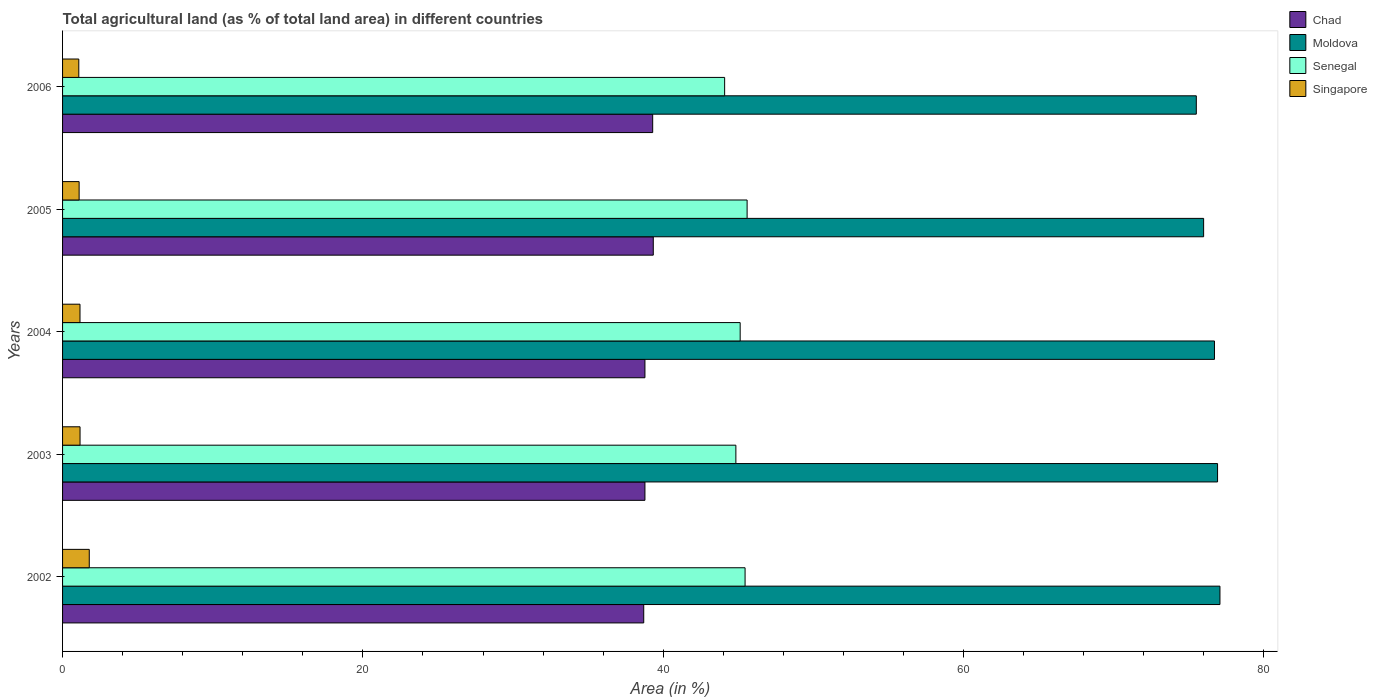Are the number of bars per tick equal to the number of legend labels?
Give a very brief answer. Yes. Are the number of bars on each tick of the Y-axis equal?
Provide a short and direct response. Yes. In how many cases, is the number of bars for a given year not equal to the number of legend labels?
Your answer should be very brief. 0. What is the percentage of agricultural land in Chad in 2002?
Your response must be concise. 38.7. Across all years, what is the maximum percentage of agricultural land in Chad?
Offer a terse response. 39.33. Across all years, what is the minimum percentage of agricultural land in Senegal?
Provide a short and direct response. 44.09. In which year was the percentage of agricultural land in Moldova maximum?
Provide a short and direct response. 2002. What is the total percentage of agricultural land in Chad in the graph?
Offer a terse response. 194.89. What is the difference between the percentage of agricultural land in Singapore in 2003 and that in 2005?
Offer a terse response. 0.06. What is the difference between the percentage of agricultural land in Chad in 2004 and the percentage of agricultural land in Senegal in 2005?
Keep it short and to the point. -6.8. What is the average percentage of agricultural land in Senegal per year?
Your answer should be compact. 45.01. In the year 2006, what is the difference between the percentage of agricultural land in Chad and percentage of agricultural land in Senegal?
Your response must be concise. -4.79. In how many years, is the percentage of agricultural land in Chad greater than 76 %?
Provide a short and direct response. 0. What is the ratio of the percentage of agricultural land in Senegal in 2004 to that in 2006?
Your answer should be compact. 1.02. What is the difference between the highest and the second highest percentage of agricultural land in Singapore?
Your response must be concise. 0.61. What is the difference between the highest and the lowest percentage of agricultural land in Chad?
Give a very brief answer. 0.64. In how many years, is the percentage of agricultural land in Singapore greater than the average percentage of agricultural land in Singapore taken over all years?
Make the answer very short. 1. Is the sum of the percentage of agricultural land in Moldova in 2003 and 2004 greater than the maximum percentage of agricultural land in Chad across all years?
Keep it short and to the point. Yes. What does the 3rd bar from the top in 2004 represents?
Ensure brevity in your answer.  Moldova. What does the 3rd bar from the bottom in 2003 represents?
Your answer should be very brief. Senegal. Is it the case that in every year, the sum of the percentage of agricultural land in Moldova and percentage of agricultural land in Senegal is greater than the percentage of agricultural land in Chad?
Keep it short and to the point. Yes. How many bars are there?
Provide a succinct answer. 20. What is the difference between two consecutive major ticks on the X-axis?
Your answer should be compact. 20. Does the graph contain grids?
Provide a succinct answer. No. How are the legend labels stacked?
Your answer should be compact. Vertical. What is the title of the graph?
Offer a very short reply. Total agricultural land (as % of total land area) in different countries. Does "Lebanon" appear as one of the legend labels in the graph?
Offer a terse response. No. What is the label or title of the X-axis?
Your response must be concise. Area (in %). What is the Area (in %) in Chad in 2002?
Your answer should be compact. 38.7. What is the Area (in %) in Moldova in 2002?
Provide a succinct answer. 77.07. What is the Area (in %) in Senegal in 2002?
Your answer should be compact. 45.45. What is the Area (in %) in Singapore in 2002?
Ensure brevity in your answer.  1.78. What is the Area (in %) in Chad in 2003?
Make the answer very short. 38.78. What is the Area (in %) of Moldova in 2003?
Give a very brief answer. 76.91. What is the Area (in %) in Senegal in 2003?
Keep it short and to the point. 44.83. What is the Area (in %) in Singapore in 2003?
Ensure brevity in your answer.  1.16. What is the Area (in %) in Chad in 2004?
Your answer should be compact. 38.78. What is the Area (in %) in Moldova in 2004?
Make the answer very short. 76.7. What is the Area (in %) of Senegal in 2004?
Provide a succinct answer. 45.12. What is the Area (in %) of Singapore in 2004?
Offer a terse response. 1.16. What is the Area (in %) in Chad in 2005?
Provide a succinct answer. 39.33. What is the Area (in %) in Moldova in 2005?
Your answer should be compact. 75.98. What is the Area (in %) of Senegal in 2005?
Ensure brevity in your answer.  45.58. What is the Area (in %) in Singapore in 2005?
Your response must be concise. 1.1. What is the Area (in %) of Chad in 2006?
Offer a terse response. 39.29. What is the Area (in %) of Moldova in 2006?
Your answer should be very brief. 75.49. What is the Area (in %) in Senegal in 2006?
Provide a short and direct response. 44.09. What is the Area (in %) of Singapore in 2006?
Keep it short and to the point. 1.08. Across all years, what is the maximum Area (in %) in Chad?
Provide a short and direct response. 39.33. Across all years, what is the maximum Area (in %) in Moldova?
Ensure brevity in your answer.  77.07. Across all years, what is the maximum Area (in %) of Senegal?
Your response must be concise. 45.58. Across all years, what is the maximum Area (in %) of Singapore?
Make the answer very short. 1.78. Across all years, what is the minimum Area (in %) of Chad?
Your answer should be compact. 38.7. Across all years, what is the minimum Area (in %) of Moldova?
Give a very brief answer. 75.49. Across all years, what is the minimum Area (in %) of Senegal?
Offer a terse response. 44.09. Across all years, what is the minimum Area (in %) of Singapore?
Offer a very short reply. 1.08. What is the total Area (in %) in Chad in the graph?
Offer a terse response. 194.89. What is the total Area (in %) of Moldova in the graph?
Offer a terse response. 382.15. What is the total Area (in %) of Senegal in the graph?
Make the answer very short. 225.07. What is the total Area (in %) of Singapore in the graph?
Offer a terse response. 6.29. What is the difference between the Area (in %) in Chad in 2002 and that in 2003?
Provide a short and direct response. -0.08. What is the difference between the Area (in %) in Moldova in 2002 and that in 2003?
Your response must be concise. 0.16. What is the difference between the Area (in %) in Senegal in 2002 and that in 2003?
Make the answer very short. 0.61. What is the difference between the Area (in %) of Singapore in 2002 and that in 2003?
Make the answer very short. 0.61. What is the difference between the Area (in %) of Chad in 2002 and that in 2004?
Your answer should be compact. -0.08. What is the difference between the Area (in %) in Moldova in 2002 and that in 2004?
Your answer should be compact. 0.36. What is the difference between the Area (in %) of Senegal in 2002 and that in 2004?
Offer a very short reply. 0.33. What is the difference between the Area (in %) of Singapore in 2002 and that in 2004?
Keep it short and to the point. 0.62. What is the difference between the Area (in %) of Chad in 2002 and that in 2005?
Make the answer very short. -0.64. What is the difference between the Area (in %) of Moldova in 2002 and that in 2005?
Make the answer very short. 1.09. What is the difference between the Area (in %) of Senegal in 2002 and that in 2005?
Give a very brief answer. -0.14. What is the difference between the Area (in %) of Singapore in 2002 and that in 2005?
Give a very brief answer. 0.67. What is the difference between the Area (in %) in Chad in 2002 and that in 2006?
Ensure brevity in your answer.  -0.6. What is the difference between the Area (in %) in Moldova in 2002 and that in 2006?
Give a very brief answer. 1.57. What is the difference between the Area (in %) in Senegal in 2002 and that in 2006?
Offer a very short reply. 1.36. What is the difference between the Area (in %) of Singapore in 2002 and that in 2006?
Your response must be concise. 0.7. What is the difference between the Area (in %) of Moldova in 2003 and that in 2004?
Give a very brief answer. 0.21. What is the difference between the Area (in %) of Senegal in 2003 and that in 2004?
Keep it short and to the point. -0.29. What is the difference between the Area (in %) of Singapore in 2003 and that in 2004?
Provide a short and direct response. 0. What is the difference between the Area (in %) in Chad in 2003 and that in 2005?
Provide a short and direct response. -0.56. What is the difference between the Area (in %) in Moldova in 2003 and that in 2005?
Your response must be concise. 0.93. What is the difference between the Area (in %) in Senegal in 2003 and that in 2005?
Provide a succinct answer. -0.75. What is the difference between the Area (in %) in Singapore in 2003 and that in 2005?
Make the answer very short. 0.06. What is the difference between the Area (in %) in Chad in 2003 and that in 2006?
Give a very brief answer. -0.52. What is the difference between the Area (in %) of Moldova in 2003 and that in 2006?
Ensure brevity in your answer.  1.42. What is the difference between the Area (in %) in Senegal in 2003 and that in 2006?
Offer a terse response. 0.75. What is the difference between the Area (in %) in Singapore in 2003 and that in 2006?
Provide a succinct answer. 0.08. What is the difference between the Area (in %) of Chad in 2004 and that in 2005?
Your response must be concise. -0.56. What is the difference between the Area (in %) in Moldova in 2004 and that in 2005?
Your answer should be very brief. 0.72. What is the difference between the Area (in %) in Senegal in 2004 and that in 2005?
Offer a very short reply. -0.46. What is the difference between the Area (in %) of Singapore in 2004 and that in 2005?
Make the answer very short. 0.06. What is the difference between the Area (in %) in Chad in 2004 and that in 2006?
Your response must be concise. -0.52. What is the difference between the Area (in %) in Moldova in 2004 and that in 2006?
Offer a very short reply. 1.21. What is the difference between the Area (in %) of Senegal in 2004 and that in 2006?
Your answer should be compact. 1.03. What is the difference between the Area (in %) of Singapore in 2004 and that in 2006?
Keep it short and to the point. 0.08. What is the difference between the Area (in %) of Chad in 2005 and that in 2006?
Ensure brevity in your answer.  0.04. What is the difference between the Area (in %) of Moldova in 2005 and that in 2006?
Offer a terse response. 0.49. What is the difference between the Area (in %) of Senegal in 2005 and that in 2006?
Offer a terse response. 1.5. What is the difference between the Area (in %) in Singapore in 2005 and that in 2006?
Your answer should be compact. 0.02. What is the difference between the Area (in %) in Chad in 2002 and the Area (in %) in Moldova in 2003?
Ensure brevity in your answer.  -38.21. What is the difference between the Area (in %) of Chad in 2002 and the Area (in %) of Senegal in 2003?
Keep it short and to the point. -6.14. What is the difference between the Area (in %) of Chad in 2002 and the Area (in %) of Singapore in 2003?
Your answer should be compact. 37.53. What is the difference between the Area (in %) in Moldova in 2002 and the Area (in %) in Senegal in 2003?
Provide a short and direct response. 32.23. What is the difference between the Area (in %) of Moldova in 2002 and the Area (in %) of Singapore in 2003?
Your response must be concise. 75.9. What is the difference between the Area (in %) of Senegal in 2002 and the Area (in %) of Singapore in 2003?
Keep it short and to the point. 44.28. What is the difference between the Area (in %) of Chad in 2002 and the Area (in %) of Moldova in 2004?
Offer a very short reply. -38. What is the difference between the Area (in %) in Chad in 2002 and the Area (in %) in Senegal in 2004?
Offer a terse response. -6.42. What is the difference between the Area (in %) in Chad in 2002 and the Area (in %) in Singapore in 2004?
Your answer should be very brief. 37.54. What is the difference between the Area (in %) of Moldova in 2002 and the Area (in %) of Senegal in 2004?
Provide a short and direct response. 31.95. What is the difference between the Area (in %) of Moldova in 2002 and the Area (in %) of Singapore in 2004?
Offer a very short reply. 75.91. What is the difference between the Area (in %) of Senegal in 2002 and the Area (in %) of Singapore in 2004?
Provide a succinct answer. 44.29. What is the difference between the Area (in %) in Chad in 2002 and the Area (in %) in Moldova in 2005?
Your answer should be compact. -37.28. What is the difference between the Area (in %) of Chad in 2002 and the Area (in %) of Senegal in 2005?
Provide a succinct answer. -6.88. What is the difference between the Area (in %) of Chad in 2002 and the Area (in %) of Singapore in 2005?
Your response must be concise. 37.6. What is the difference between the Area (in %) in Moldova in 2002 and the Area (in %) in Senegal in 2005?
Your answer should be very brief. 31.49. What is the difference between the Area (in %) in Moldova in 2002 and the Area (in %) in Singapore in 2005?
Make the answer very short. 75.97. What is the difference between the Area (in %) of Senegal in 2002 and the Area (in %) of Singapore in 2005?
Provide a succinct answer. 44.34. What is the difference between the Area (in %) of Chad in 2002 and the Area (in %) of Moldova in 2006?
Your answer should be very brief. -36.79. What is the difference between the Area (in %) of Chad in 2002 and the Area (in %) of Senegal in 2006?
Your answer should be very brief. -5.39. What is the difference between the Area (in %) of Chad in 2002 and the Area (in %) of Singapore in 2006?
Make the answer very short. 37.62. What is the difference between the Area (in %) in Moldova in 2002 and the Area (in %) in Senegal in 2006?
Offer a very short reply. 32.98. What is the difference between the Area (in %) of Moldova in 2002 and the Area (in %) of Singapore in 2006?
Offer a very short reply. 75.99. What is the difference between the Area (in %) in Senegal in 2002 and the Area (in %) in Singapore in 2006?
Your response must be concise. 44.37. What is the difference between the Area (in %) in Chad in 2003 and the Area (in %) in Moldova in 2004?
Keep it short and to the point. -37.92. What is the difference between the Area (in %) of Chad in 2003 and the Area (in %) of Senegal in 2004?
Your answer should be very brief. -6.34. What is the difference between the Area (in %) of Chad in 2003 and the Area (in %) of Singapore in 2004?
Your answer should be very brief. 37.62. What is the difference between the Area (in %) of Moldova in 2003 and the Area (in %) of Senegal in 2004?
Your answer should be compact. 31.79. What is the difference between the Area (in %) in Moldova in 2003 and the Area (in %) in Singapore in 2004?
Make the answer very short. 75.75. What is the difference between the Area (in %) of Senegal in 2003 and the Area (in %) of Singapore in 2004?
Provide a short and direct response. 43.67. What is the difference between the Area (in %) of Chad in 2003 and the Area (in %) of Moldova in 2005?
Provide a short and direct response. -37.2. What is the difference between the Area (in %) in Chad in 2003 and the Area (in %) in Senegal in 2005?
Give a very brief answer. -6.8. What is the difference between the Area (in %) of Chad in 2003 and the Area (in %) of Singapore in 2005?
Your answer should be very brief. 37.68. What is the difference between the Area (in %) in Moldova in 2003 and the Area (in %) in Senegal in 2005?
Your response must be concise. 31.33. What is the difference between the Area (in %) in Moldova in 2003 and the Area (in %) in Singapore in 2005?
Offer a very short reply. 75.81. What is the difference between the Area (in %) of Senegal in 2003 and the Area (in %) of Singapore in 2005?
Make the answer very short. 43.73. What is the difference between the Area (in %) of Chad in 2003 and the Area (in %) of Moldova in 2006?
Ensure brevity in your answer.  -36.72. What is the difference between the Area (in %) in Chad in 2003 and the Area (in %) in Senegal in 2006?
Offer a very short reply. -5.31. What is the difference between the Area (in %) of Chad in 2003 and the Area (in %) of Singapore in 2006?
Keep it short and to the point. 37.7. What is the difference between the Area (in %) of Moldova in 2003 and the Area (in %) of Senegal in 2006?
Make the answer very short. 32.82. What is the difference between the Area (in %) in Moldova in 2003 and the Area (in %) in Singapore in 2006?
Your answer should be compact. 75.83. What is the difference between the Area (in %) in Senegal in 2003 and the Area (in %) in Singapore in 2006?
Make the answer very short. 43.75. What is the difference between the Area (in %) in Chad in 2004 and the Area (in %) in Moldova in 2005?
Keep it short and to the point. -37.2. What is the difference between the Area (in %) in Chad in 2004 and the Area (in %) in Senegal in 2005?
Provide a succinct answer. -6.8. What is the difference between the Area (in %) of Chad in 2004 and the Area (in %) of Singapore in 2005?
Provide a short and direct response. 37.68. What is the difference between the Area (in %) of Moldova in 2004 and the Area (in %) of Senegal in 2005?
Offer a terse response. 31.12. What is the difference between the Area (in %) of Moldova in 2004 and the Area (in %) of Singapore in 2005?
Provide a succinct answer. 75.6. What is the difference between the Area (in %) of Senegal in 2004 and the Area (in %) of Singapore in 2005?
Your answer should be very brief. 44.02. What is the difference between the Area (in %) of Chad in 2004 and the Area (in %) of Moldova in 2006?
Offer a very short reply. -36.72. What is the difference between the Area (in %) in Chad in 2004 and the Area (in %) in Senegal in 2006?
Provide a succinct answer. -5.31. What is the difference between the Area (in %) of Chad in 2004 and the Area (in %) of Singapore in 2006?
Your answer should be very brief. 37.7. What is the difference between the Area (in %) in Moldova in 2004 and the Area (in %) in Senegal in 2006?
Keep it short and to the point. 32.62. What is the difference between the Area (in %) of Moldova in 2004 and the Area (in %) of Singapore in 2006?
Provide a succinct answer. 75.62. What is the difference between the Area (in %) of Senegal in 2004 and the Area (in %) of Singapore in 2006?
Your answer should be compact. 44.04. What is the difference between the Area (in %) of Chad in 2005 and the Area (in %) of Moldova in 2006?
Your answer should be very brief. -36.16. What is the difference between the Area (in %) in Chad in 2005 and the Area (in %) in Senegal in 2006?
Your answer should be very brief. -4.75. What is the difference between the Area (in %) in Chad in 2005 and the Area (in %) in Singapore in 2006?
Give a very brief answer. 38.25. What is the difference between the Area (in %) in Moldova in 2005 and the Area (in %) in Senegal in 2006?
Your answer should be very brief. 31.89. What is the difference between the Area (in %) of Moldova in 2005 and the Area (in %) of Singapore in 2006?
Provide a short and direct response. 74.9. What is the difference between the Area (in %) in Senegal in 2005 and the Area (in %) in Singapore in 2006?
Give a very brief answer. 44.5. What is the average Area (in %) in Chad per year?
Keep it short and to the point. 38.98. What is the average Area (in %) of Moldova per year?
Offer a terse response. 76.43. What is the average Area (in %) of Senegal per year?
Ensure brevity in your answer.  45.01. What is the average Area (in %) in Singapore per year?
Provide a succinct answer. 1.26. In the year 2002, what is the difference between the Area (in %) of Chad and Area (in %) of Moldova?
Your answer should be very brief. -38.37. In the year 2002, what is the difference between the Area (in %) in Chad and Area (in %) in Senegal?
Your answer should be very brief. -6.75. In the year 2002, what is the difference between the Area (in %) of Chad and Area (in %) of Singapore?
Keep it short and to the point. 36.92. In the year 2002, what is the difference between the Area (in %) in Moldova and Area (in %) in Senegal?
Ensure brevity in your answer.  31.62. In the year 2002, what is the difference between the Area (in %) of Moldova and Area (in %) of Singapore?
Your answer should be very brief. 75.29. In the year 2002, what is the difference between the Area (in %) in Senegal and Area (in %) in Singapore?
Your answer should be compact. 43.67. In the year 2003, what is the difference between the Area (in %) of Chad and Area (in %) of Moldova?
Your answer should be very brief. -38.13. In the year 2003, what is the difference between the Area (in %) of Chad and Area (in %) of Senegal?
Provide a short and direct response. -6.06. In the year 2003, what is the difference between the Area (in %) in Chad and Area (in %) in Singapore?
Ensure brevity in your answer.  37.61. In the year 2003, what is the difference between the Area (in %) in Moldova and Area (in %) in Senegal?
Offer a very short reply. 32.07. In the year 2003, what is the difference between the Area (in %) in Moldova and Area (in %) in Singapore?
Give a very brief answer. 75.74. In the year 2003, what is the difference between the Area (in %) in Senegal and Area (in %) in Singapore?
Your answer should be very brief. 43.67. In the year 2004, what is the difference between the Area (in %) of Chad and Area (in %) of Moldova?
Your response must be concise. -37.92. In the year 2004, what is the difference between the Area (in %) in Chad and Area (in %) in Senegal?
Keep it short and to the point. -6.34. In the year 2004, what is the difference between the Area (in %) of Chad and Area (in %) of Singapore?
Offer a terse response. 37.62. In the year 2004, what is the difference between the Area (in %) of Moldova and Area (in %) of Senegal?
Keep it short and to the point. 31.58. In the year 2004, what is the difference between the Area (in %) in Moldova and Area (in %) in Singapore?
Offer a very short reply. 75.54. In the year 2004, what is the difference between the Area (in %) of Senegal and Area (in %) of Singapore?
Provide a succinct answer. 43.96. In the year 2005, what is the difference between the Area (in %) in Chad and Area (in %) in Moldova?
Provide a succinct answer. -36.65. In the year 2005, what is the difference between the Area (in %) in Chad and Area (in %) in Senegal?
Offer a very short reply. -6.25. In the year 2005, what is the difference between the Area (in %) in Chad and Area (in %) in Singapore?
Offer a very short reply. 38.23. In the year 2005, what is the difference between the Area (in %) of Moldova and Area (in %) of Senegal?
Make the answer very short. 30.4. In the year 2005, what is the difference between the Area (in %) of Moldova and Area (in %) of Singapore?
Give a very brief answer. 74.88. In the year 2005, what is the difference between the Area (in %) of Senegal and Area (in %) of Singapore?
Provide a succinct answer. 44.48. In the year 2006, what is the difference between the Area (in %) of Chad and Area (in %) of Moldova?
Give a very brief answer. -36.2. In the year 2006, what is the difference between the Area (in %) of Chad and Area (in %) of Senegal?
Give a very brief answer. -4.79. In the year 2006, what is the difference between the Area (in %) in Chad and Area (in %) in Singapore?
Provide a short and direct response. 38.21. In the year 2006, what is the difference between the Area (in %) of Moldova and Area (in %) of Senegal?
Ensure brevity in your answer.  31.41. In the year 2006, what is the difference between the Area (in %) of Moldova and Area (in %) of Singapore?
Provide a short and direct response. 74.41. In the year 2006, what is the difference between the Area (in %) of Senegal and Area (in %) of Singapore?
Give a very brief answer. 43.01. What is the ratio of the Area (in %) of Chad in 2002 to that in 2003?
Offer a terse response. 1. What is the ratio of the Area (in %) in Moldova in 2002 to that in 2003?
Offer a terse response. 1. What is the ratio of the Area (in %) in Senegal in 2002 to that in 2003?
Make the answer very short. 1.01. What is the ratio of the Area (in %) in Singapore in 2002 to that in 2003?
Offer a very short reply. 1.53. What is the ratio of the Area (in %) in Chad in 2002 to that in 2004?
Your response must be concise. 1. What is the ratio of the Area (in %) of Moldova in 2002 to that in 2004?
Your answer should be compact. 1. What is the ratio of the Area (in %) in Senegal in 2002 to that in 2004?
Keep it short and to the point. 1.01. What is the ratio of the Area (in %) of Singapore in 2002 to that in 2004?
Provide a succinct answer. 1.53. What is the ratio of the Area (in %) in Chad in 2002 to that in 2005?
Your answer should be very brief. 0.98. What is the ratio of the Area (in %) in Moldova in 2002 to that in 2005?
Ensure brevity in your answer.  1.01. What is the ratio of the Area (in %) in Senegal in 2002 to that in 2005?
Provide a short and direct response. 1. What is the ratio of the Area (in %) of Singapore in 2002 to that in 2005?
Offer a very short reply. 1.61. What is the ratio of the Area (in %) of Moldova in 2002 to that in 2006?
Make the answer very short. 1.02. What is the ratio of the Area (in %) of Senegal in 2002 to that in 2006?
Offer a very short reply. 1.03. What is the ratio of the Area (in %) in Singapore in 2002 to that in 2006?
Your answer should be very brief. 1.65. What is the ratio of the Area (in %) in Moldova in 2003 to that in 2004?
Offer a terse response. 1. What is the ratio of the Area (in %) of Singapore in 2003 to that in 2004?
Provide a succinct answer. 1. What is the ratio of the Area (in %) of Chad in 2003 to that in 2005?
Your answer should be very brief. 0.99. What is the ratio of the Area (in %) in Moldova in 2003 to that in 2005?
Offer a terse response. 1.01. What is the ratio of the Area (in %) in Senegal in 2003 to that in 2005?
Your response must be concise. 0.98. What is the ratio of the Area (in %) of Singapore in 2003 to that in 2005?
Your response must be concise. 1.06. What is the ratio of the Area (in %) of Chad in 2003 to that in 2006?
Your answer should be compact. 0.99. What is the ratio of the Area (in %) of Moldova in 2003 to that in 2006?
Offer a very short reply. 1.02. What is the ratio of the Area (in %) of Singapore in 2003 to that in 2006?
Provide a short and direct response. 1.08. What is the ratio of the Area (in %) in Chad in 2004 to that in 2005?
Your answer should be very brief. 0.99. What is the ratio of the Area (in %) in Moldova in 2004 to that in 2005?
Provide a succinct answer. 1.01. What is the ratio of the Area (in %) in Senegal in 2004 to that in 2005?
Make the answer very short. 0.99. What is the ratio of the Area (in %) in Singapore in 2004 to that in 2005?
Offer a very short reply. 1.05. What is the ratio of the Area (in %) of Chad in 2004 to that in 2006?
Offer a very short reply. 0.99. What is the ratio of the Area (in %) in Senegal in 2004 to that in 2006?
Your response must be concise. 1.02. What is the ratio of the Area (in %) of Singapore in 2004 to that in 2006?
Offer a terse response. 1.07. What is the ratio of the Area (in %) in Chad in 2005 to that in 2006?
Offer a terse response. 1. What is the ratio of the Area (in %) in Moldova in 2005 to that in 2006?
Your answer should be compact. 1.01. What is the ratio of the Area (in %) in Senegal in 2005 to that in 2006?
Give a very brief answer. 1.03. What is the ratio of the Area (in %) of Singapore in 2005 to that in 2006?
Your response must be concise. 1.02. What is the difference between the highest and the second highest Area (in %) of Chad?
Your answer should be very brief. 0.04. What is the difference between the highest and the second highest Area (in %) in Moldova?
Provide a succinct answer. 0.16. What is the difference between the highest and the second highest Area (in %) of Senegal?
Offer a very short reply. 0.14. What is the difference between the highest and the second highest Area (in %) in Singapore?
Your answer should be compact. 0.61. What is the difference between the highest and the lowest Area (in %) of Chad?
Provide a short and direct response. 0.64. What is the difference between the highest and the lowest Area (in %) in Moldova?
Keep it short and to the point. 1.57. What is the difference between the highest and the lowest Area (in %) of Senegal?
Provide a short and direct response. 1.5. What is the difference between the highest and the lowest Area (in %) in Singapore?
Provide a succinct answer. 0.7. 